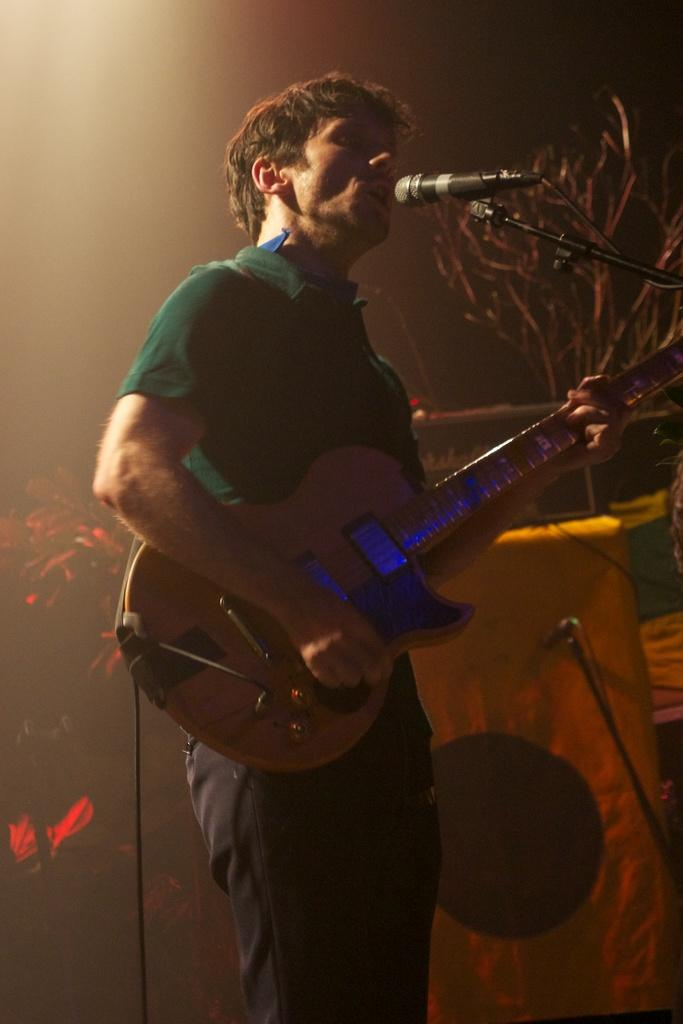Who is the main subject in the image? There is a man in the image. What is the man doing in the image? The man is standing, playing the guitar, and singing on a microphone. What type of wood can be seen in the image? There is no wood present in the image. How many pigs are visible in the image? There are no pigs present in the image. 